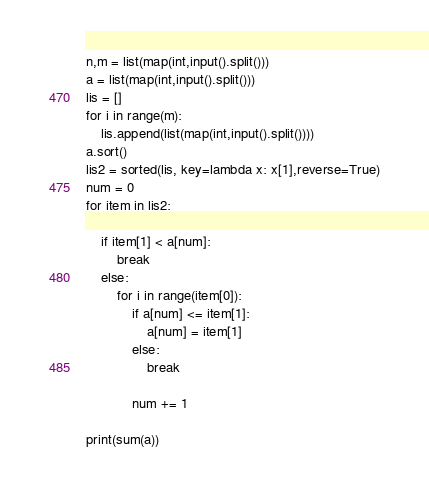Convert code to text. <code><loc_0><loc_0><loc_500><loc_500><_Python_>n,m = list(map(int,input().split()))
a = list(map(int,input().split()))
lis = []
for i in range(m):
    lis.append(list(map(int,input().split())))
a.sort()
lis2 = sorted(lis, key=lambda x: x[1],reverse=True)
num = 0
for item in lis2:

    if item[1] < a[num]:
        break
    else:
        for i in range(item[0]):
            if a[num] <= item[1]:
                a[num] = item[1]
            else:
                break

            num += 1

print(sum(a))
</code> 